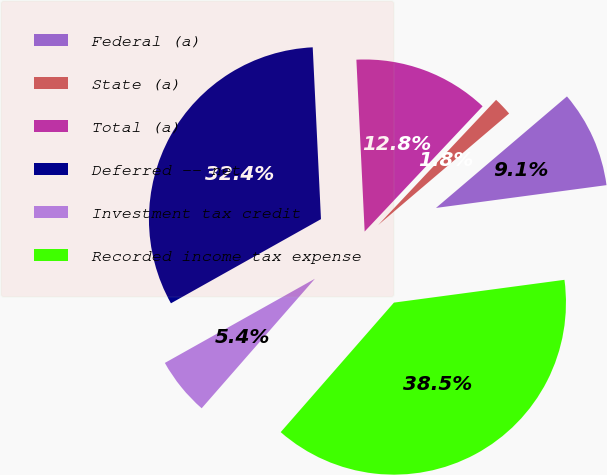Convert chart to OTSL. <chart><loc_0><loc_0><loc_500><loc_500><pie_chart><fcel>Federal (a)<fcel>State (a)<fcel>Total (a)<fcel>Deferred -- net<fcel>Investment tax credit<fcel>Recorded income tax expense<nl><fcel>9.11%<fcel>1.75%<fcel>12.79%<fcel>32.37%<fcel>5.43%<fcel>38.55%<nl></chart> 